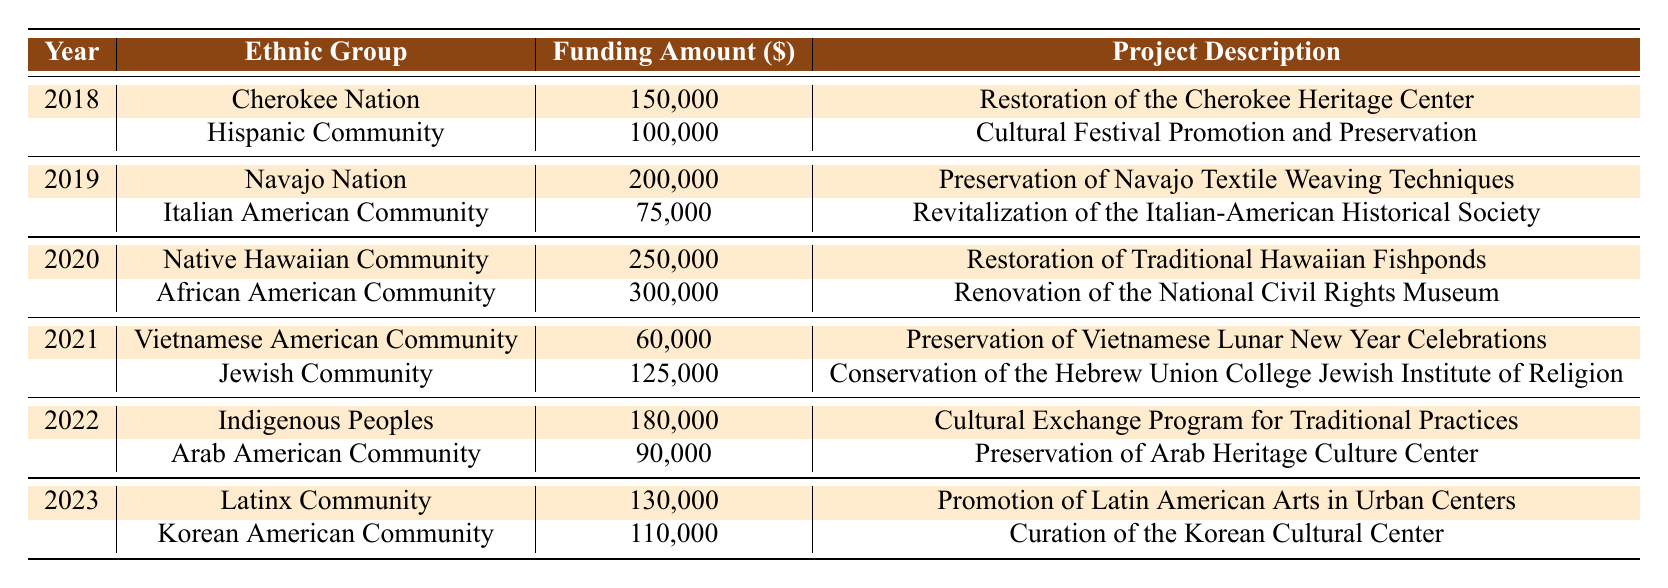What is the total funding amount for the Cherokee Nation in 2018? The table shows that in 2018, the funding amount for the Cherokee Nation is 150,000. There are no other entries for this group in 2018.
Answer: 150,000 How much funding was allocated to Hispanic Community projects in 2018? In the table, the Hispanic Community received a funding amount of 100,000 in 2018 as listed under that year.
Answer: 100,000 Which ethnic group received the highest funding in 2020? In 2020, the Native Hawaiian Community received 250,000 and the African American Community received 300,000. The highest funding is for the African American Community.
Answer: African American Community What is the average funding amount for all projects listed in 2021? The total funding for 2021 is 60,000 (Vietnamese American Community) + 125,000 (Jewish Community) = 185,000. Since there are 2 projects, the average is 185,000 divided by 2, which equals 92,500.
Answer: 92,500 Did any ethnic group not receive funding in 2019? The table shows that the only entries for 2019 are for the Navajo Nation and the Italian American Community, so no ethnic group went without funding that year.
Answer: No How much total funding was provided for the projects in 2022? Adding the funding amounts for 2022, we have 180,000 (Indigenous Peoples) + 90,000 (Arab American Community) = 270,000.
Answer: 270,000 Which year featured the highest total funding allocated across all projects? In 2020, the funding was 250,000 (Native Hawaiian Community) + 300,000 (African American Community) = 550,000. In comparison, 2019 had 275,000, and 2021 had 185,000. Therefore, 2020 had the highest total funding.
Answer: 2020 What percentage of the total funding in 2023 was allocated to Korean American Community projects? In 2023, the total funding was 130,000 (Latinx Community) + 110,000 (Korean American Community) = 240,000. The Korean American Community received 110,000, which is (110,000/240,000) * 100 = 45.83%.
Answer: 45.83% How does the funding amount for Native Hawaiian Community in 2020 compare to that of the Vietnamese American Community in 2021? The Native Hawaiian Community received 250,000 in 2020 whereas the Vietnamese American Community received 60,000 in 2021. The difference, 250,000 - 60,000, is 190,000.
Answer: 190,000 Has the funding for the Jewish Community increased, decreased, or remained the same from 2021 to 2023? The funding for the Jewish Community in 2021 was 125,000 and in 2023, the Korean American Community received 110,000. Hence, for comparison, Jewish funding remained the same, and the Korean funding is lower.
Answer: Decreased 